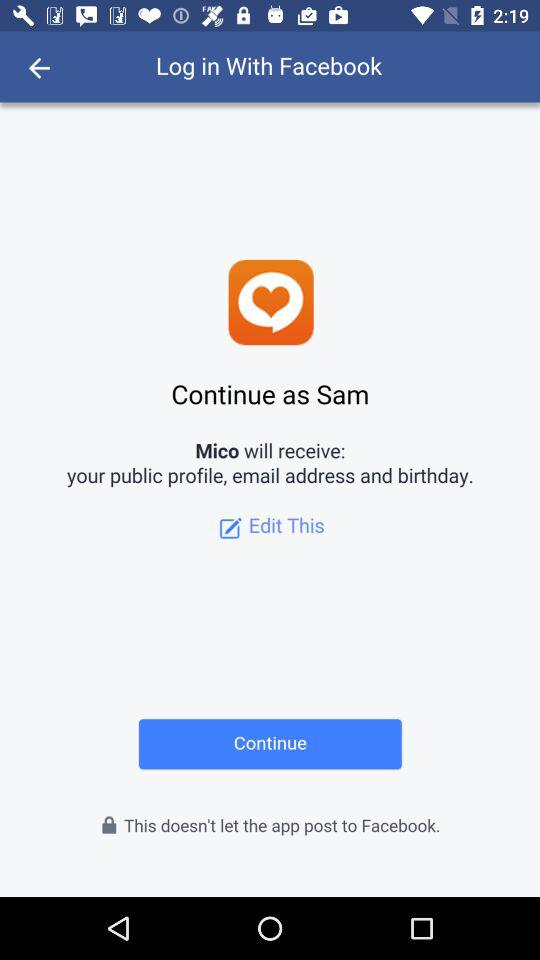What application is asking for permission? The application asking for permission is "Mico". 